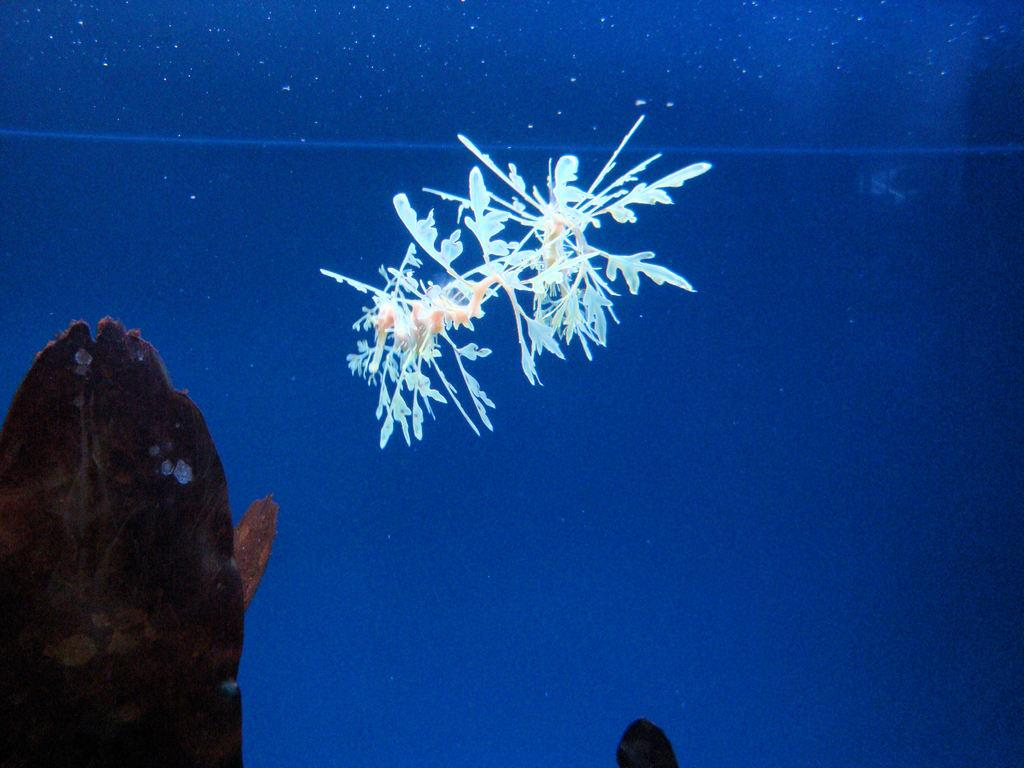What is the main subject of the image? The main subject of the image is a plant. Can you describe the color of the plant? The plant is in white color. How is the plant situated in the image? The plant is in water. What is the color of the background in the image? The background of the image is in blue color. What object can be seen on the left side of the image? There is an object in brown color on the left side of the image. What note does the writer leave on the plant in the image? There is no writer or note present in the image; it only features a white plant in water with a blue background and a brown object on the left side. 